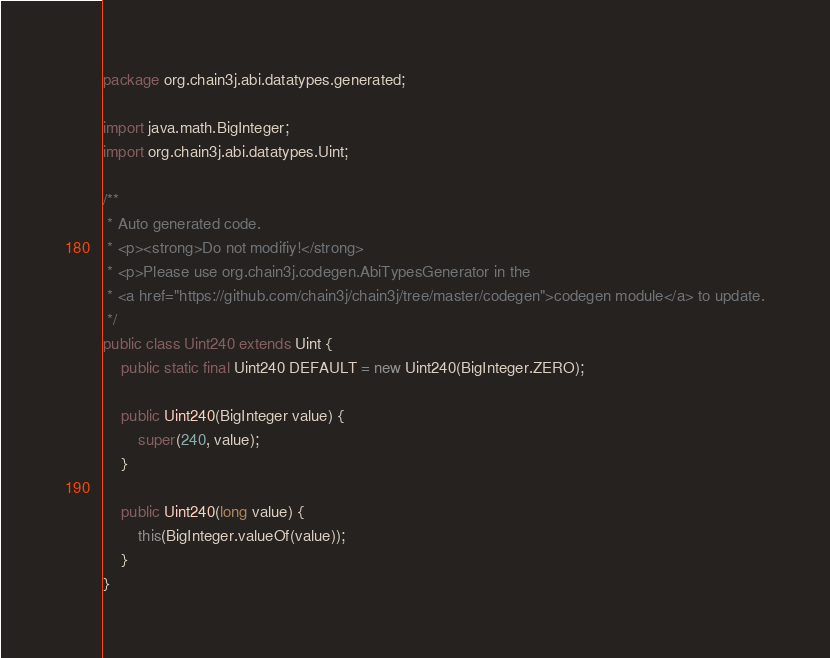Convert code to text. <code><loc_0><loc_0><loc_500><loc_500><_Java_>package org.chain3j.abi.datatypes.generated;

import java.math.BigInteger;
import org.chain3j.abi.datatypes.Uint;

/**
 * Auto generated code.
 * <p><strong>Do not modifiy!</strong>
 * <p>Please use org.chain3j.codegen.AbiTypesGenerator in the 
 * <a href="https://github.com/chain3j/chain3j/tree/master/codegen">codegen module</a> to update.
 */
public class Uint240 extends Uint {
    public static final Uint240 DEFAULT = new Uint240(BigInteger.ZERO);

    public Uint240(BigInteger value) {
        super(240, value);
    }

    public Uint240(long value) {
        this(BigInteger.valueOf(value));
    }
}
</code> 